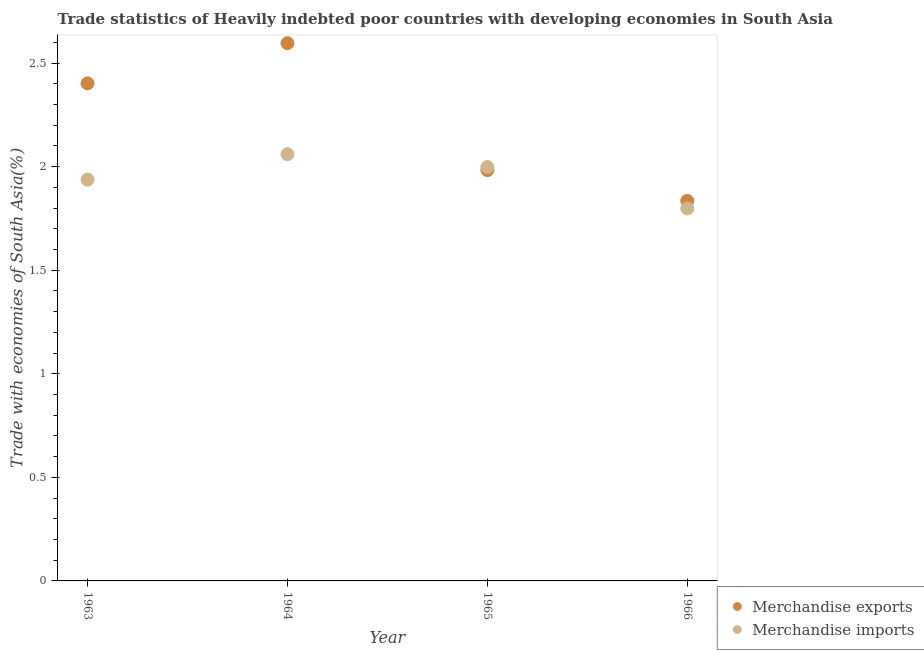How many different coloured dotlines are there?
Ensure brevity in your answer.  2. What is the merchandise exports in 1964?
Make the answer very short. 2.6. Across all years, what is the maximum merchandise imports?
Offer a terse response. 2.06. Across all years, what is the minimum merchandise imports?
Offer a terse response. 1.8. In which year was the merchandise imports maximum?
Offer a terse response. 1964. In which year was the merchandise exports minimum?
Offer a very short reply. 1966. What is the total merchandise imports in the graph?
Your answer should be compact. 7.79. What is the difference between the merchandise exports in 1964 and that in 1966?
Provide a succinct answer. 0.76. What is the difference between the merchandise imports in 1965 and the merchandise exports in 1964?
Offer a very short reply. -0.6. What is the average merchandise exports per year?
Provide a succinct answer. 2.2. In the year 1964, what is the difference between the merchandise exports and merchandise imports?
Offer a terse response. 0.54. What is the ratio of the merchandise exports in 1965 to that in 1966?
Provide a short and direct response. 1.08. Is the merchandise exports in 1964 less than that in 1965?
Make the answer very short. No. Is the difference between the merchandise exports in 1964 and 1966 greater than the difference between the merchandise imports in 1964 and 1966?
Keep it short and to the point. Yes. What is the difference between the highest and the second highest merchandise exports?
Your answer should be compact. 0.19. What is the difference between the highest and the lowest merchandise imports?
Your response must be concise. 0.26. Is the sum of the merchandise exports in 1963 and 1966 greater than the maximum merchandise imports across all years?
Provide a short and direct response. Yes. How many dotlines are there?
Offer a very short reply. 2. Does the graph contain any zero values?
Provide a succinct answer. No. Where does the legend appear in the graph?
Offer a very short reply. Bottom right. How many legend labels are there?
Give a very brief answer. 2. What is the title of the graph?
Keep it short and to the point. Trade statistics of Heavily indebted poor countries with developing economies in South Asia. Does "Food" appear as one of the legend labels in the graph?
Keep it short and to the point. No. What is the label or title of the Y-axis?
Offer a terse response. Trade with economies of South Asia(%). What is the Trade with economies of South Asia(%) in Merchandise exports in 1963?
Provide a short and direct response. 2.4. What is the Trade with economies of South Asia(%) of Merchandise imports in 1963?
Ensure brevity in your answer.  1.94. What is the Trade with economies of South Asia(%) in Merchandise exports in 1964?
Your response must be concise. 2.6. What is the Trade with economies of South Asia(%) of Merchandise imports in 1964?
Offer a very short reply. 2.06. What is the Trade with economies of South Asia(%) of Merchandise exports in 1965?
Your response must be concise. 1.98. What is the Trade with economies of South Asia(%) in Merchandise imports in 1965?
Keep it short and to the point. 2. What is the Trade with economies of South Asia(%) in Merchandise exports in 1966?
Provide a short and direct response. 1.83. What is the Trade with economies of South Asia(%) in Merchandise imports in 1966?
Your answer should be very brief. 1.8. Across all years, what is the maximum Trade with economies of South Asia(%) of Merchandise exports?
Offer a terse response. 2.6. Across all years, what is the maximum Trade with economies of South Asia(%) in Merchandise imports?
Your answer should be very brief. 2.06. Across all years, what is the minimum Trade with economies of South Asia(%) of Merchandise exports?
Provide a succinct answer. 1.83. Across all years, what is the minimum Trade with economies of South Asia(%) of Merchandise imports?
Offer a very short reply. 1.8. What is the total Trade with economies of South Asia(%) of Merchandise exports in the graph?
Ensure brevity in your answer.  8.82. What is the total Trade with economies of South Asia(%) of Merchandise imports in the graph?
Give a very brief answer. 7.79. What is the difference between the Trade with economies of South Asia(%) of Merchandise exports in 1963 and that in 1964?
Provide a short and direct response. -0.19. What is the difference between the Trade with economies of South Asia(%) of Merchandise imports in 1963 and that in 1964?
Your answer should be very brief. -0.12. What is the difference between the Trade with economies of South Asia(%) of Merchandise exports in 1963 and that in 1965?
Your answer should be very brief. 0.42. What is the difference between the Trade with economies of South Asia(%) in Merchandise imports in 1963 and that in 1965?
Make the answer very short. -0.06. What is the difference between the Trade with economies of South Asia(%) in Merchandise exports in 1963 and that in 1966?
Ensure brevity in your answer.  0.57. What is the difference between the Trade with economies of South Asia(%) in Merchandise imports in 1963 and that in 1966?
Make the answer very short. 0.14. What is the difference between the Trade with economies of South Asia(%) of Merchandise exports in 1964 and that in 1965?
Make the answer very short. 0.61. What is the difference between the Trade with economies of South Asia(%) in Merchandise imports in 1964 and that in 1965?
Ensure brevity in your answer.  0.06. What is the difference between the Trade with economies of South Asia(%) in Merchandise exports in 1964 and that in 1966?
Provide a short and direct response. 0.76. What is the difference between the Trade with economies of South Asia(%) in Merchandise imports in 1964 and that in 1966?
Give a very brief answer. 0.26. What is the difference between the Trade with economies of South Asia(%) in Merchandise exports in 1965 and that in 1966?
Provide a succinct answer. 0.15. What is the difference between the Trade with economies of South Asia(%) of Merchandise imports in 1965 and that in 1966?
Give a very brief answer. 0.2. What is the difference between the Trade with economies of South Asia(%) of Merchandise exports in 1963 and the Trade with economies of South Asia(%) of Merchandise imports in 1964?
Make the answer very short. 0.34. What is the difference between the Trade with economies of South Asia(%) of Merchandise exports in 1963 and the Trade with economies of South Asia(%) of Merchandise imports in 1965?
Your answer should be compact. 0.4. What is the difference between the Trade with economies of South Asia(%) in Merchandise exports in 1963 and the Trade with economies of South Asia(%) in Merchandise imports in 1966?
Your answer should be very brief. 0.6. What is the difference between the Trade with economies of South Asia(%) in Merchandise exports in 1964 and the Trade with economies of South Asia(%) in Merchandise imports in 1965?
Your answer should be compact. 0.6. What is the difference between the Trade with economies of South Asia(%) of Merchandise exports in 1964 and the Trade with economies of South Asia(%) of Merchandise imports in 1966?
Offer a very short reply. 0.8. What is the difference between the Trade with economies of South Asia(%) in Merchandise exports in 1965 and the Trade with economies of South Asia(%) in Merchandise imports in 1966?
Your answer should be compact. 0.18. What is the average Trade with economies of South Asia(%) of Merchandise exports per year?
Offer a very short reply. 2.2. What is the average Trade with economies of South Asia(%) in Merchandise imports per year?
Your answer should be very brief. 1.95. In the year 1963, what is the difference between the Trade with economies of South Asia(%) of Merchandise exports and Trade with economies of South Asia(%) of Merchandise imports?
Give a very brief answer. 0.46. In the year 1964, what is the difference between the Trade with economies of South Asia(%) of Merchandise exports and Trade with economies of South Asia(%) of Merchandise imports?
Offer a terse response. 0.54. In the year 1965, what is the difference between the Trade with economies of South Asia(%) of Merchandise exports and Trade with economies of South Asia(%) of Merchandise imports?
Ensure brevity in your answer.  -0.01. In the year 1966, what is the difference between the Trade with economies of South Asia(%) of Merchandise exports and Trade with economies of South Asia(%) of Merchandise imports?
Your answer should be compact. 0.04. What is the ratio of the Trade with economies of South Asia(%) in Merchandise exports in 1963 to that in 1964?
Your response must be concise. 0.93. What is the ratio of the Trade with economies of South Asia(%) of Merchandise imports in 1963 to that in 1964?
Keep it short and to the point. 0.94. What is the ratio of the Trade with economies of South Asia(%) of Merchandise exports in 1963 to that in 1965?
Make the answer very short. 1.21. What is the ratio of the Trade with economies of South Asia(%) of Merchandise imports in 1963 to that in 1965?
Keep it short and to the point. 0.97. What is the ratio of the Trade with economies of South Asia(%) of Merchandise exports in 1963 to that in 1966?
Your answer should be very brief. 1.31. What is the ratio of the Trade with economies of South Asia(%) of Merchandise imports in 1963 to that in 1966?
Keep it short and to the point. 1.08. What is the ratio of the Trade with economies of South Asia(%) in Merchandise exports in 1964 to that in 1965?
Offer a terse response. 1.31. What is the ratio of the Trade with economies of South Asia(%) in Merchandise imports in 1964 to that in 1965?
Ensure brevity in your answer.  1.03. What is the ratio of the Trade with economies of South Asia(%) in Merchandise exports in 1964 to that in 1966?
Give a very brief answer. 1.42. What is the ratio of the Trade with economies of South Asia(%) in Merchandise imports in 1964 to that in 1966?
Make the answer very short. 1.15. What is the ratio of the Trade with economies of South Asia(%) in Merchandise exports in 1965 to that in 1966?
Offer a very short reply. 1.08. What is the ratio of the Trade with economies of South Asia(%) of Merchandise imports in 1965 to that in 1966?
Make the answer very short. 1.11. What is the difference between the highest and the second highest Trade with economies of South Asia(%) of Merchandise exports?
Provide a short and direct response. 0.19. What is the difference between the highest and the second highest Trade with economies of South Asia(%) in Merchandise imports?
Your answer should be compact. 0.06. What is the difference between the highest and the lowest Trade with economies of South Asia(%) in Merchandise exports?
Your answer should be compact. 0.76. What is the difference between the highest and the lowest Trade with economies of South Asia(%) of Merchandise imports?
Offer a very short reply. 0.26. 